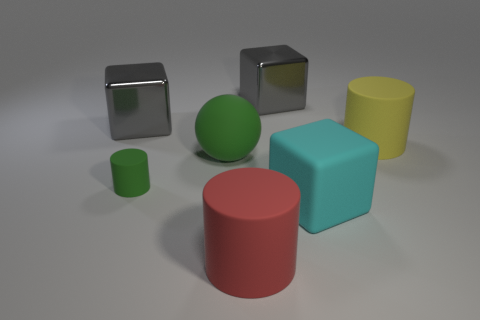Are there any other things that are the same size as the green cylinder?
Give a very brief answer. No. There is a rubber object that is both left of the big red matte cylinder and behind the small cylinder; what shape is it?
Ensure brevity in your answer.  Sphere. There is a gray cube to the right of the large red thing that is in front of the green ball; are there any gray metal things that are to the left of it?
Your response must be concise. Yes. Do the big red object to the right of the big green matte object and the large cyan object have the same material?
Provide a succinct answer. Yes. What material is the cylinder that is both left of the cyan matte cube and on the right side of the big green matte thing?
Offer a very short reply. Rubber. What color is the metal cube that is left of the tiny green cylinder to the left of the large yellow thing?
Provide a succinct answer. Gray. There is a large red thing that is the same shape as the tiny green object; what is its material?
Offer a terse response. Rubber. The rubber cylinder in front of the cylinder that is left of the big ball that is behind the tiny thing is what color?
Make the answer very short. Red. What number of yellow rubber things are the same shape as the large red thing?
Provide a short and direct response. 1. Do the green cylinder and the big red cylinder in front of the green rubber cylinder have the same material?
Your response must be concise. Yes. 